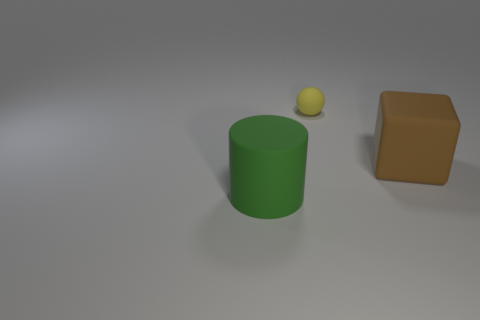Is there any other thing that is the same size as the yellow rubber sphere?
Give a very brief answer. No. Is there a green thing left of the big rubber object to the right of the big green thing?
Ensure brevity in your answer.  Yes. There is a large rubber cube; are there any large rubber objects to the left of it?
Offer a very short reply. Yes. Is there a object made of the same material as the cylinder?
Your answer should be compact. Yes. The thing that is in front of the large thing right of the yellow ball is made of what material?
Provide a succinct answer. Rubber. What is the size of the rubber object behind the large brown matte object?
Give a very brief answer. Small. Are the brown cube and the large thing left of the yellow object made of the same material?
Keep it short and to the point. Yes. What number of small objects are either brown objects or balls?
Offer a very short reply. 1. Is the number of tiny objects less than the number of red shiny cubes?
Your answer should be compact. No. There is a matte object to the left of the small yellow thing; is it the same size as the thing behind the matte cube?
Provide a short and direct response. No. 